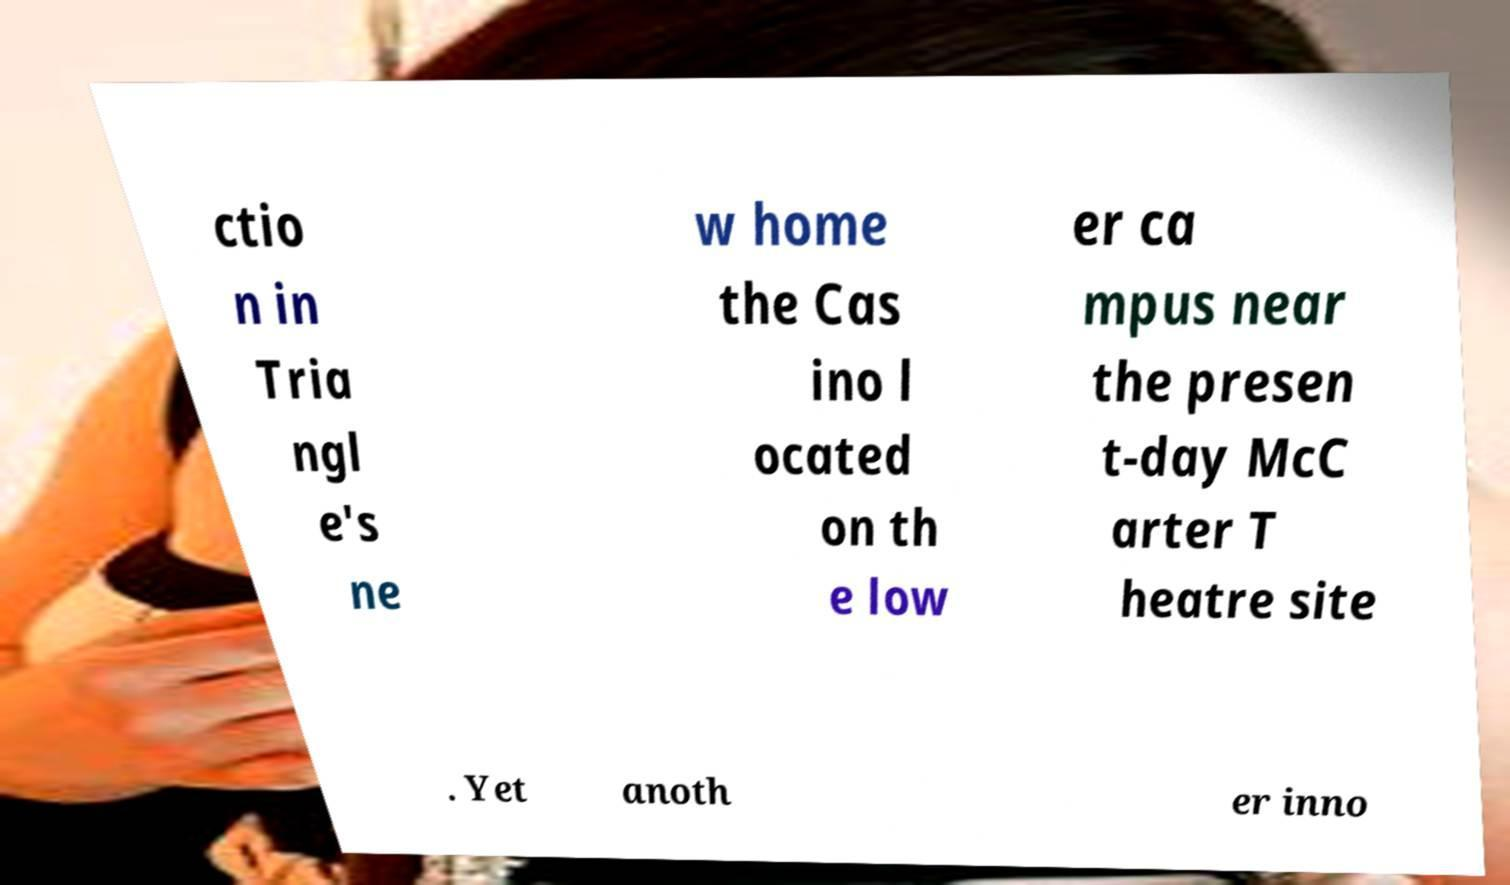Can you accurately transcribe the text from the provided image for me? ctio n in Tria ngl e's ne w home the Cas ino l ocated on th e low er ca mpus near the presen t-day McC arter T heatre site . Yet anoth er inno 